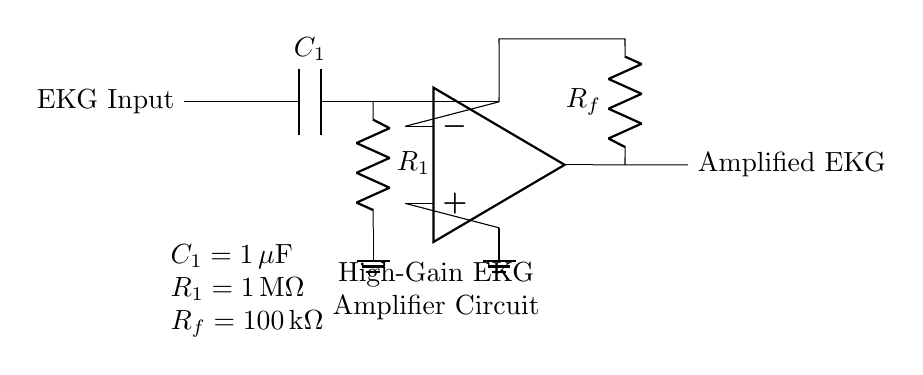What is the value of C1? The circuit shows that the capacitor connected to the input has a label indicating its value as 1 microfarad.
Answer: 1 microfarad What is the total gain of the amplifier circuit? The gain can be determined by the feedback resistor and input resistor values using the formula for an inverting amplifier. With Rf at 100 kilohms and R1 at 1 megohm, the gain would be -Rf/R1, which equals -0.1 or -10%.
Answer: -0.1 What type of filter is present in this circuit? The circuit includes a capacitor and resistor in series; this configuration acts as a high-pass filter, which allows high-frequency signals to pass and attenuates lower frequencies.
Answer: High-pass filter What is the role of R1 in the circuit? R1 serves as the input resistor in the high-pass filter configuration, determining the cut-off frequency with C1. It also contributes to the overall gain of the amplifier.
Answer: Input resistor Where is the ground reference in the circuit? The ground reference is indicated by a node labeled ground, which is connected to the non-inverting input of the operational amplifier and also at the bottom of the resistor in the high-pass filter.
Answer: At the bottom of R1 and the non-inverting input of the op-amp 